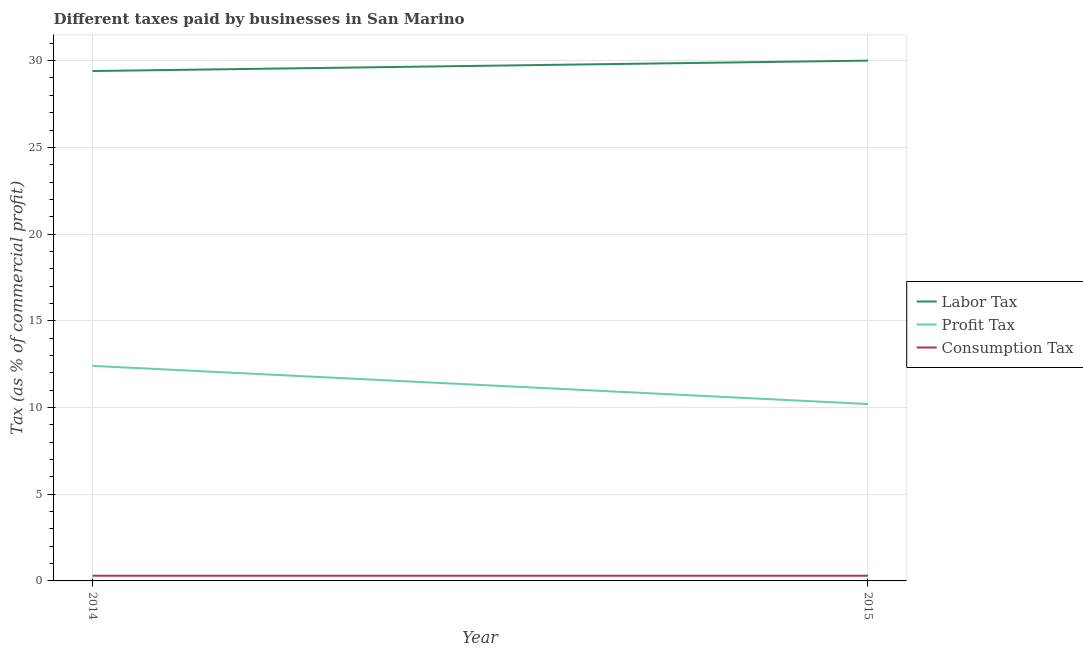How many different coloured lines are there?
Provide a short and direct response. 3. Does the line corresponding to percentage of profit tax intersect with the line corresponding to percentage of labor tax?
Your response must be concise. No. Across all years, what is the maximum percentage of labor tax?
Keep it short and to the point. 30. Across all years, what is the minimum percentage of profit tax?
Your answer should be compact. 10.2. What is the total percentage of consumption tax in the graph?
Keep it short and to the point. 0.6. What is the difference between the percentage of profit tax in 2014 and that in 2015?
Provide a succinct answer. 2.2. What is the difference between the percentage of labor tax in 2015 and the percentage of consumption tax in 2014?
Offer a very short reply. 29.7. What is the average percentage of consumption tax per year?
Your answer should be compact. 0.3. In the year 2015, what is the difference between the percentage of profit tax and percentage of consumption tax?
Give a very brief answer. 9.9. In how many years, is the percentage of profit tax greater than 10 %?
Your answer should be compact. 2. What is the ratio of the percentage of labor tax in 2014 to that in 2015?
Your answer should be very brief. 0.98. Is the percentage of labor tax in 2014 less than that in 2015?
Ensure brevity in your answer.  Yes. In how many years, is the percentage of profit tax greater than the average percentage of profit tax taken over all years?
Your answer should be very brief. 1. Is it the case that in every year, the sum of the percentage of labor tax and percentage of profit tax is greater than the percentage of consumption tax?
Provide a succinct answer. Yes. How many lines are there?
Keep it short and to the point. 3. Does the graph contain any zero values?
Keep it short and to the point. No. How many legend labels are there?
Your answer should be very brief. 3. How are the legend labels stacked?
Provide a succinct answer. Vertical. What is the title of the graph?
Provide a succinct answer. Different taxes paid by businesses in San Marino. What is the label or title of the Y-axis?
Provide a succinct answer. Tax (as % of commercial profit). What is the Tax (as % of commercial profit) in Labor Tax in 2014?
Offer a very short reply. 29.4. What is the Tax (as % of commercial profit) in Consumption Tax in 2015?
Provide a succinct answer. 0.3. Across all years, what is the maximum Tax (as % of commercial profit) of Profit Tax?
Offer a terse response. 12.4. Across all years, what is the minimum Tax (as % of commercial profit) of Labor Tax?
Provide a short and direct response. 29.4. Across all years, what is the minimum Tax (as % of commercial profit) of Profit Tax?
Keep it short and to the point. 10.2. What is the total Tax (as % of commercial profit) of Labor Tax in the graph?
Offer a very short reply. 59.4. What is the total Tax (as % of commercial profit) in Profit Tax in the graph?
Give a very brief answer. 22.6. What is the total Tax (as % of commercial profit) of Consumption Tax in the graph?
Make the answer very short. 0.6. What is the difference between the Tax (as % of commercial profit) in Labor Tax in 2014 and that in 2015?
Give a very brief answer. -0.6. What is the difference between the Tax (as % of commercial profit) in Consumption Tax in 2014 and that in 2015?
Offer a very short reply. 0. What is the difference between the Tax (as % of commercial profit) in Labor Tax in 2014 and the Tax (as % of commercial profit) in Consumption Tax in 2015?
Ensure brevity in your answer.  29.1. What is the average Tax (as % of commercial profit) in Labor Tax per year?
Keep it short and to the point. 29.7. What is the average Tax (as % of commercial profit) of Profit Tax per year?
Give a very brief answer. 11.3. What is the average Tax (as % of commercial profit) in Consumption Tax per year?
Provide a succinct answer. 0.3. In the year 2014, what is the difference between the Tax (as % of commercial profit) of Labor Tax and Tax (as % of commercial profit) of Profit Tax?
Your answer should be compact. 17. In the year 2014, what is the difference between the Tax (as % of commercial profit) of Labor Tax and Tax (as % of commercial profit) of Consumption Tax?
Provide a short and direct response. 29.1. In the year 2015, what is the difference between the Tax (as % of commercial profit) of Labor Tax and Tax (as % of commercial profit) of Profit Tax?
Offer a very short reply. 19.8. In the year 2015, what is the difference between the Tax (as % of commercial profit) of Labor Tax and Tax (as % of commercial profit) of Consumption Tax?
Provide a short and direct response. 29.7. In the year 2015, what is the difference between the Tax (as % of commercial profit) of Profit Tax and Tax (as % of commercial profit) of Consumption Tax?
Offer a terse response. 9.9. What is the ratio of the Tax (as % of commercial profit) in Labor Tax in 2014 to that in 2015?
Provide a short and direct response. 0.98. What is the ratio of the Tax (as % of commercial profit) in Profit Tax in 2014 to that in 2015?
Provide a succinct answer. 1.22. What is the ratio of the Tax (as % of commercial profit) in Consumption Tax in 2014 to that in 2015?
Your answer should be very brief. 1. What is the difference between the highest and the second highest Tax (as % of commercial profit) in Labor Tax?
Ensure brevity in your answer.  0.6. What is the difference between the highest and the lowest Tax (as % of commercial profit) in Labor Tax?
Provide a succinct answer. 0.6. What is the difference between the highest and the lowest Tax (as % of commercial profit) of Consumption Tax?
Your answer should be very brief. 0. 